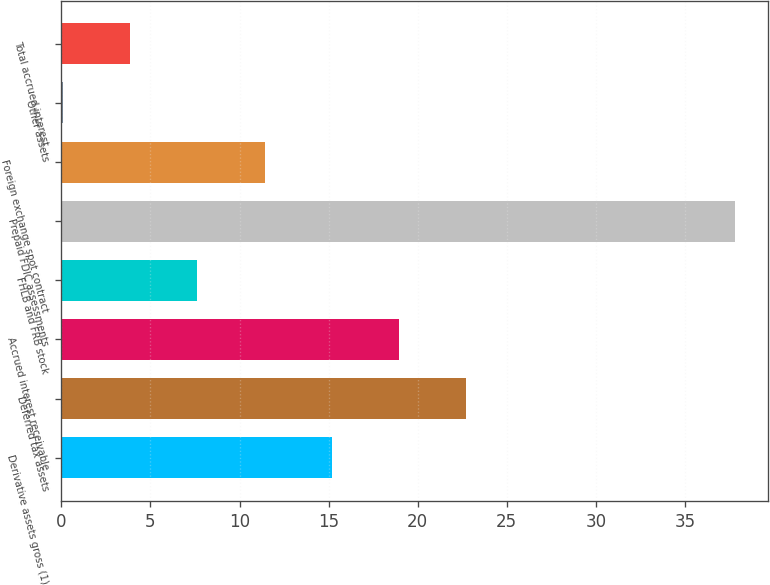Convert chart to OTSL. <chart><loc_0><loc_0><loc_500><loc_500><bar_chart><fcel>Derivative assets gross (1)<fcel>Deferred tax assets<fcel>Accrued interest receivable<fcel>FHLB and FRB stock<fcel>Prepaid FDIC assessments<fcel>Foreign exchange spot contract<fcel>Other assets<fcel>Total accrued interest<nl><fcel>15.18<fcel>22.72<fcel>18.95<fcel>7.64<fcel>37.8<fcel>11.41<fcel>0.1<fcel>3.87<nl></chart> 